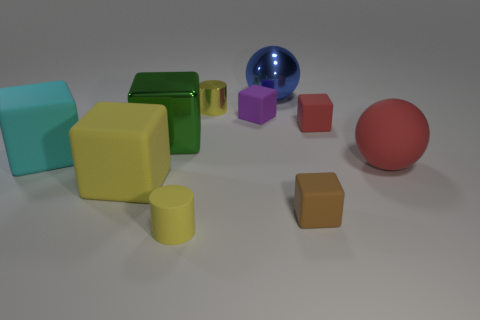Subtract 2 blocks. How many blocks are left? 4 Subtract all cyan blocks. How many blocks are left? 5 Subtract all purple blocks. How many blocks are left? 5 Subtract all blue cubes. Subtract all yellow cylinders. How many cubes are left? 6 Subtract all blocks. How many objects are left? 4 Add 3 tiny brown rubber cubes. How many tiny brown rubber cubes are left? 4 Add 6 big blocks. How many big blocks exist? 9 Subtract 0 cyan cylinders. How many objects are left? 10 Subtract all blue balls. Subtract all yellow metal objects. How many objects are left? 8 